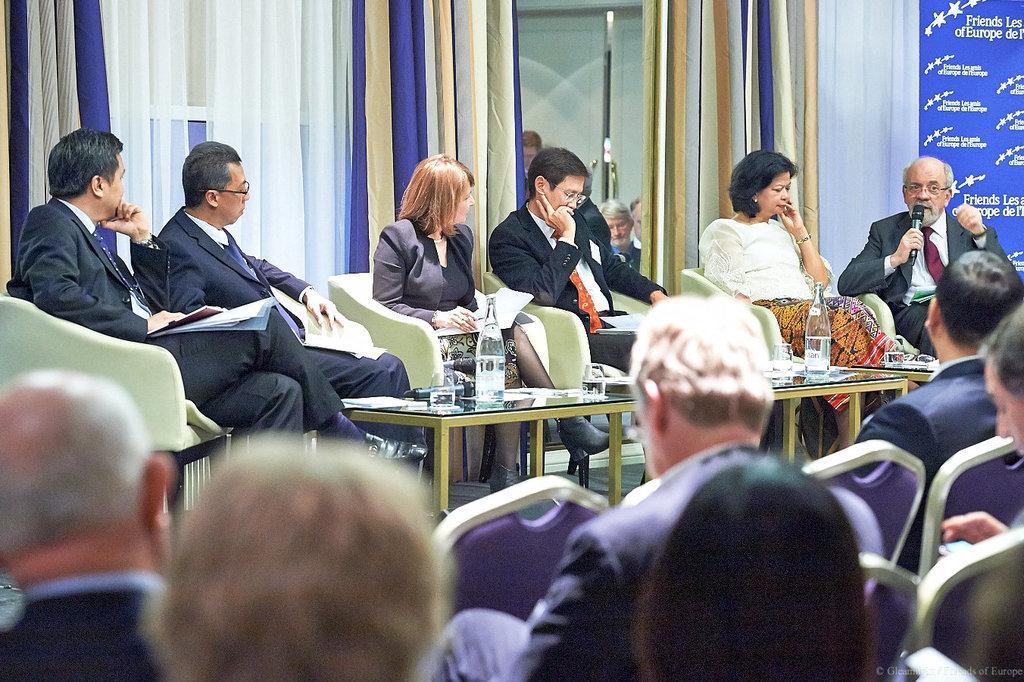Please provide a concise description of this image. In this image there are people sitting on chairs, in front of them there is a stage, on that stage there are people sitting on chairs in the middle there is a table on that table their bottles, glasses and mics and one person is holding mic in his hand, on the right side top there is a poster on that poster there is some text. 